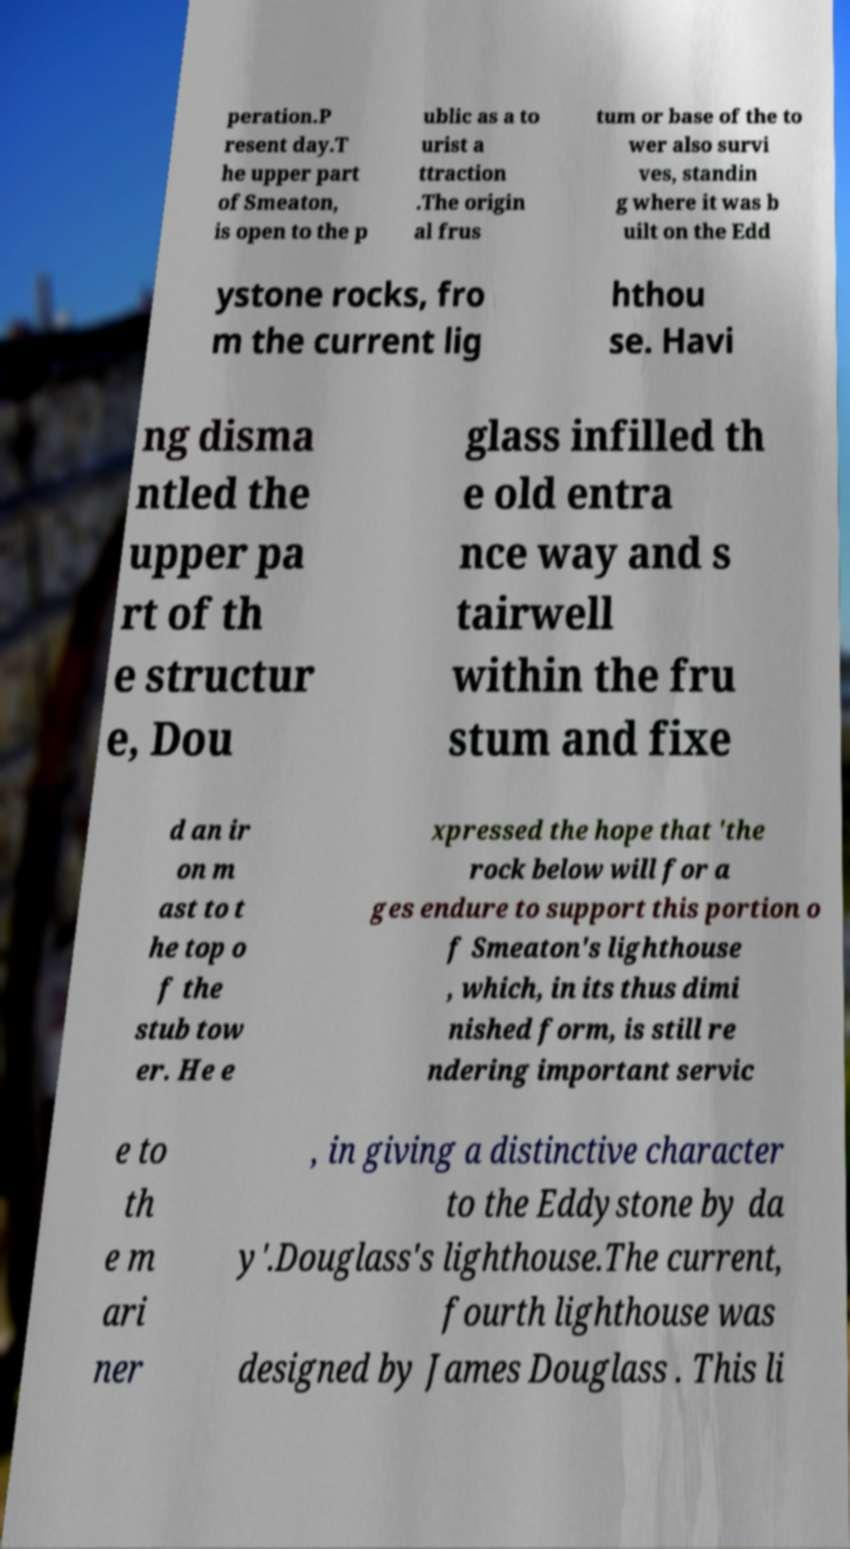What messages or text are displayed in this image? I need them in a readable, typed format. peration.P resent day.T he upper part of Smeaton, is open to the p ublic as a to urist a ttraction .The origin al frus tum or base of the to wer also survi ves, standin g where it was b uilt on the Edd ystone rocks, fro m the current lig hthou se. Havi ng disma ntled the upper pa rt of th e structur e, Dou glass infilled th e old entra nce way and s tairwell within the fru stum and fixe d an ir on m ast to t he top o f the stub tow er. He e xpressed the hope that 'the rock below will for a ges endure to support this portion o f Smeaton's lighthouse , which, in its thus dimi nished form, is still re ndering important servic e to th e m ari ner , in giving a distinctive character to the Eddystone by da y'.Douglass's lighthouse.The current, fourth lighthouse was designed by James Douglass . This li 